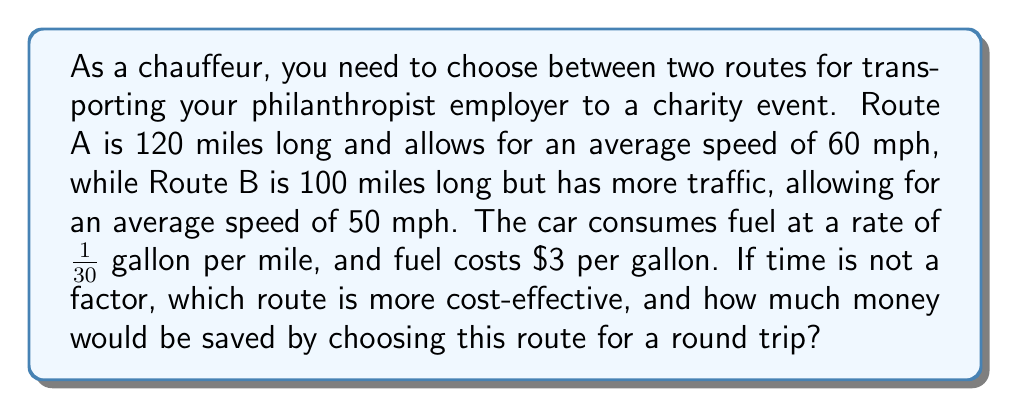Help me with this question. Let's approach this step-by-step:

1) First, calculate the fuel consumption for each route:
   Route A: $120 \text{ miles} \times \frac{1}{30} \text{ gallon/mile} = 4 \text{ gallons}$
   Route B: $100 \text{ miles} \times \frac{1}{30} \text{ gallon/mile} = \frac{10}{3} \text{ gallons}$

2) Now, calculate the fuel cost for each route:
   Route A: $4 \text{ gallons} \times \$3/\text{gallon} = \$12$
   Route B: $\frac{10}{3} \text{ gallons} \times \$3/\text{gallon} = \$10$

3) For a round trip, double these costs:
   Route A: $\$12 \times 2 = \$24$
   Route B: $\$10 \times 2 = \$20$

4) Calculate the difference in cost:
   $\$24 - \$20 = \$4$

Therefore, Route B is more cost-effective, saving $4 for the round trip.
Answer: Route B; $4 saved 